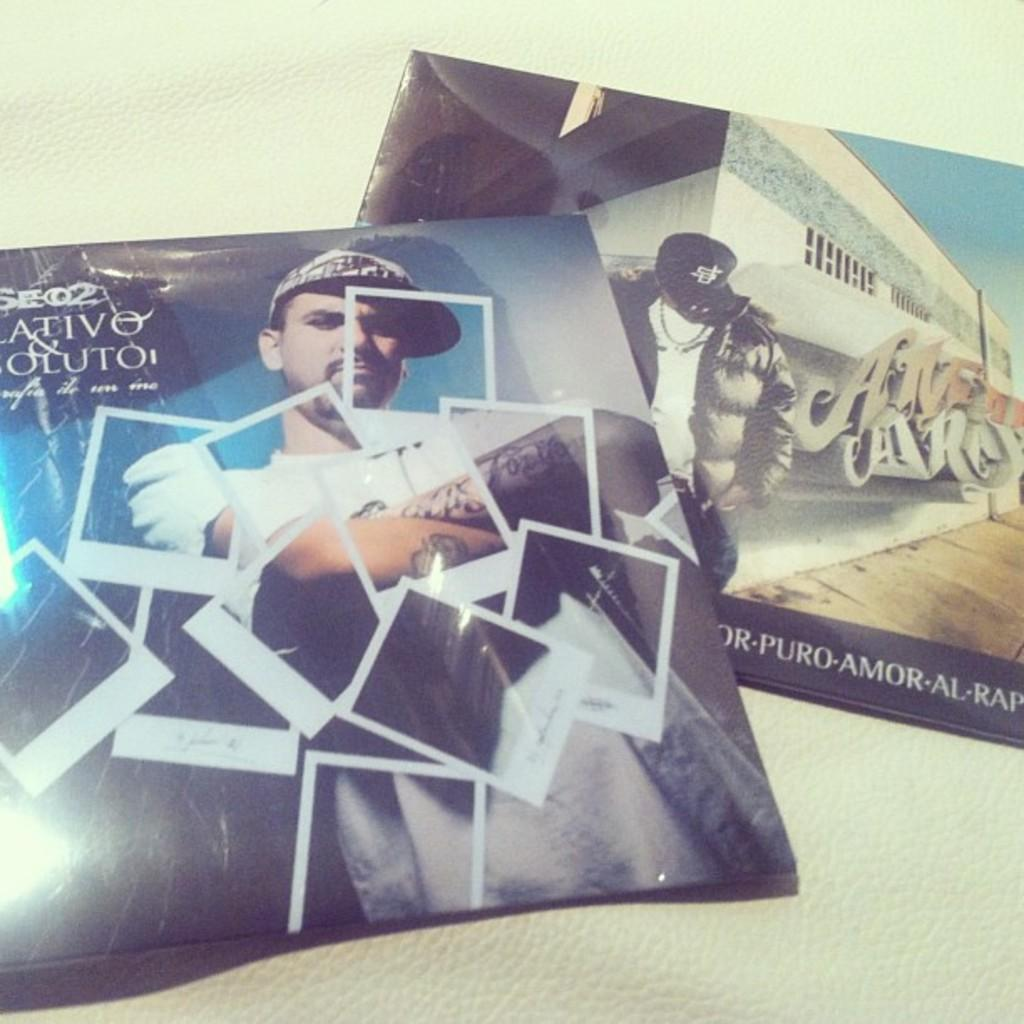What type of printed material is present in the image? There are flyers in the image. What information can be found on the flyers? The flyers contain text. Are there any visual elements on the flyers? Yes, the flyers have human images. What can be seen behind the flyers in the image? There is a plain surface in the background of the image. What type of tank is visible in the image? There is no tank present in the image; it features flyers with text and human images. How many elbows can be seen in the image? There are no elbows visible in the image, as it only contains flyers with text and human images. 